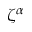Convert formula to latex. <formula><loc_0><loc_0><loc_500><loc_500>\zeta ^ { \alpha }</formula> 